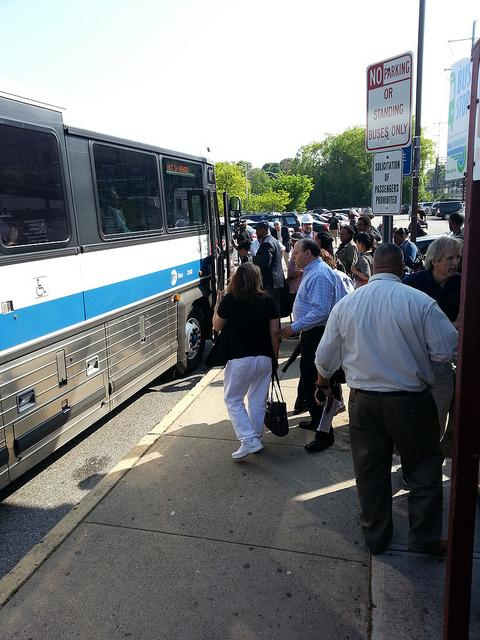What activity is prohibited here? Please explain your reasoning. taxis. Taxis are prohibited from entering here, buses only. 